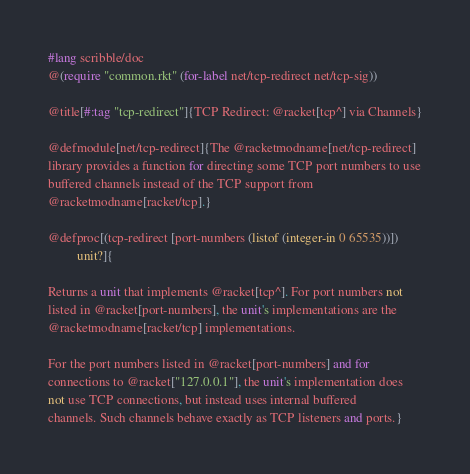Convert code to text. <code><loc_0><loc_0><loc_500><loc_500><_Racket_>#lang scribble/doc
@(require "common.rkt" (for-label net/tcp-redirect net/tcp-sig))

@title[#:tag "tcp-redirect"]{TCP Redirect: @racket[tcp^] via Channels}

@defmodule[net/tcp-redirect]{The @racketmodname[net/tcp-redirect]
library provides a function for directing some TCP port numbers to use
buffered channels instead of the TCP support from
@racketmodname[racket/tcp].}

@defproc[(tcp-redirect [port-numbers (listof (integer-in 0 65535))])
         unit?]{

Returns a unit that implements @racket[tcp^]. For port numbers not
listed in @racket[port-numbers], the unit's implementations are the
@racketmodname[racket/tcp] implementations.

For the port numbers listed in @racket[port-numbers] and for
connections to @racket["127.0.0.1"], the unit's implementation does
not use TCP connections, but instead uses internal buffered
channels. Such channels behave exactly as TCP listeners and ports.}
</code> 